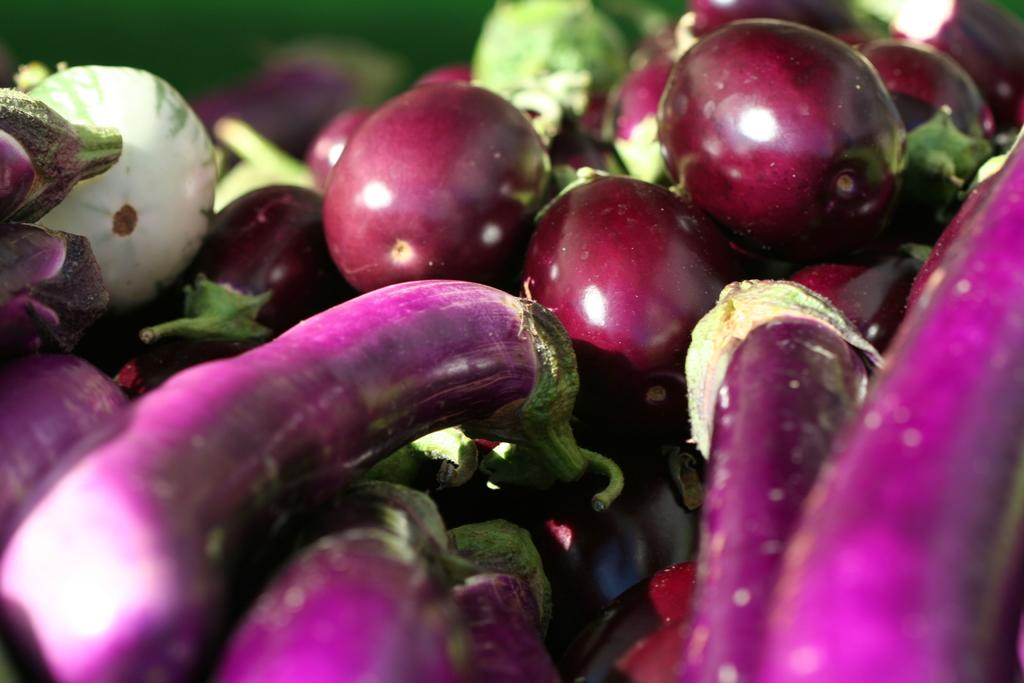What type of vegetable is present in the image? There are a few aubergines in the image. What type of brake system can be seen on the aubergines in the image? There is no brake system present on the aubergines in the image, as they are vegetables and not vehicles. 